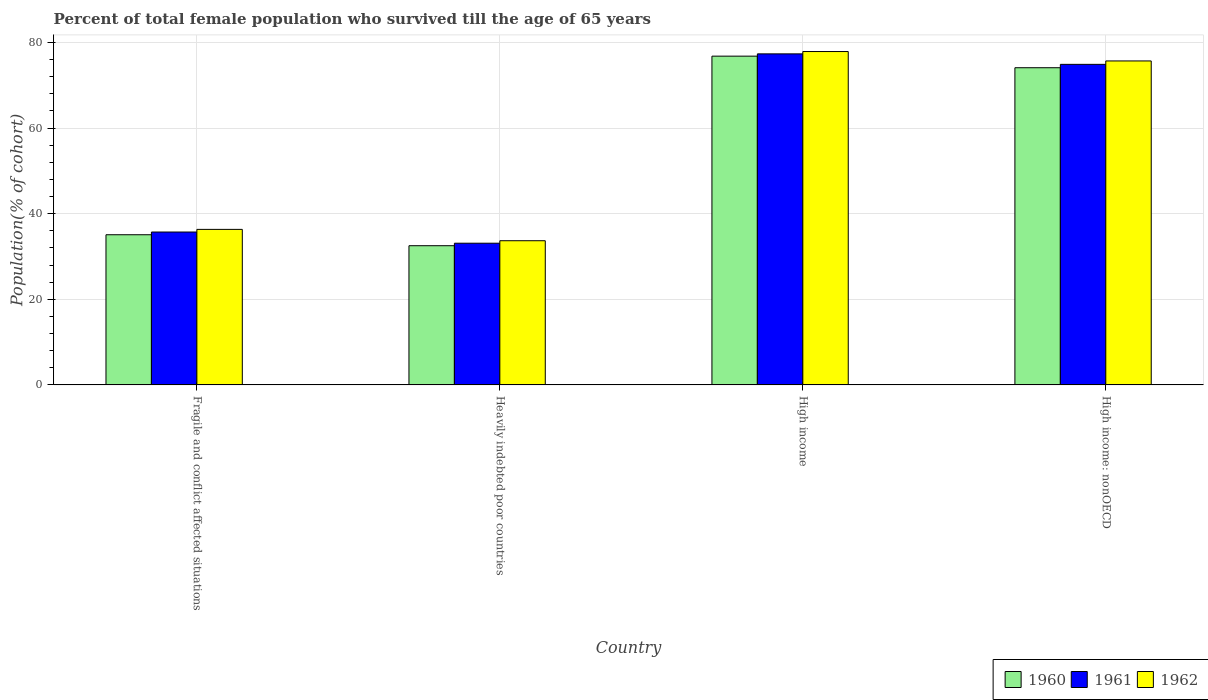How many different coloured bars are there?
Ensure brevity in your answer.  3. Are the number of bars per tick equal to the number of legend labels?
Provide a succinct answer. Yes. How many bars are there on the 4th tick from the left?
Your answer should be compact. 3. How many bars are there on the 3rd tick from the right?
Ensure brevity in your answer.  3. What is the label of the 2nd group of bars from the left?
Offer a terse response. Heavily indebted poor countries. What is the percentage of total female population who survived till the age of 65 years in 1962 in Fragile and conflict affected situations?
Offer a very short reply. 36.34. Across all countries, what is the maximum percentage of total female population who survived till the age of 65 years in 1961?
Your answer should be very brief. 77.34. Across all countries, what is the minimum percentage of total female population who survived till the age of 65 years in 1960?
Provide a short and direct response. 32.52. In which country was the percentage of total female population who survived till the age of 65 years in 1961 maximum?
Ensure brevity in your answer.  High income. In which country was the percentage of total female population who survived till the age of 65 years in 1962 minimum?
Your answer should be very brief. Heavily indebted poor countries. What is the total percentage of total female population who survived till the age of 65 years in 1961 in the graph?
Offer a very short reply. 221.06. What is the difference between the percentage of total female population who survived till the age of 65 years in 1960 in Heavily indebted poor countries and that in High income: nonOECD?
Ensure brevity in your answer.  -41.58. What is the difference between the percentage of total female population who survived till the age of 65 years in 1960 in Fragile and conflict affected situations and the percentage of total female population who survived till the age of 65 years in 1962 in High income?
Offer a terse response. -42.8. What is the average percentage of total female population who survived till the age of 65 years in 1960 per country?
Give a very brief answer. 54.63. What is the difference between the percentage of total female population who survived till the age of 65 years of/in 1962 and percentage of total female population who survived till the age of 65 years of/in 1961 in Fragile and conflict affected situations?
Ensure brevity in your answer.  0.62. What is the ratio of the percentage of total female population who survived till the age of 65 years in 1962 in Fragile and conflict affected situations to that in High income: nonOECD?
Offer a very short reply. 0.48. What is the difference between the highest and the second highest percentage of total female population who survived till the age of 65 years in 1962?
Provide a succinct answer. 39.35. What is the difference between the highest and the lowest percentage of total female population who survived till the age of 65 years in 1960?
Provide a succinct answer. 44.29. In how many countries, is the percentage of total female population who survived till the age of 65 years in 1960 greater than the average percentage of total female population who survived till the age of 65 years in 1960 taken over all countries?
Your answer should be compact. 2. What does the 1st bar from the left in High income: nonOECD represents?
Your answer should be compact. 1960. How many bars are there?
Provide a succinct answer. 12. Are the values on the major ticks of Y-axis written in scientific E-notation?
Your answer should be compact. No. Does the graph contain any zero values?
Your answer should be very brief. No. Does the graph contain grids?
Your answer should be very brief. Yes. How many legend labels are there?
Provide a short and direct response. 3. What is the title of the graph?
Provide a succinct answer. Percent of total female population who survived till the age of 65 years. Does "2000" appear as one of the legend labels in the graph?
Your answer should be very brief. No. What is the label or title of the X-axis?
Your answer should be compact. Country. What is the label or title of the Y-axis?
Offer a very short reply. Population(% of cohort). What is the Population(% of cohort) in 1960 in Fragile and conflict affected situations?
Ensure brevity in your answer.  35.08. What is the Population(% of cohort) in 1961 in Fragile and conflict affected situations?
Make the answer very short. 35.72. What is the Population(% of cohort) in 1962 in Fragile and conflict affected situations?
Give a very brief answer. 36.34. What is the Population(% of cohort) in 1960 in Heavily indebted poor countries?
Make the answer very short. 32.52. What is the Population(% of cohort) in 1961 in Heavily indebted poor countries?
Provide a succinct answer. 33.1. What is the Population(% of cohort) of 1962 in Heavily indebted poor countries?
Offer a very short reply. 33.69. What is the Population(% of cohort) in 1960 in High income?
Your answer should be compact. 76.81. What is the Population(% of cohort) in 1961 in High income?
Offer a very short reply. 77.34. What is the Population(% of cohort) in 1962 in High income?
Your response must be concise. 77.88. What is the Population(% of cohort) of 1960 in High income: nonOECD?
Keep it short and to the point. 74.1. What is the Population(% of cohort) in 1961 in High income: nonOECD?
Offer a very short reply. 74.89. What is the Population(% of cohort) in 1962 in High income: nonOECD?
Offer a very short reply. 75.69. Across all countries, what is the maximum Population(% of cohort) of 1960?
Offer a very short reply. 76.81. Across all countries, what is the maximum Population(% of cohort) of 1961?
Keep it short and to the point. 77.34. Across all countries, what is the maximum Population(% of cohort) in 1962?
Your answer should be compact. 77.88. Across all countries, what is the minimum Population(% of cohort) in 1960?
Offer a very short reply. 32.52. Across all countries, what is the minimum Population(% of cohort) in 1961?
Offer a very short reply. 33.1. Across all countries, what is the minimum Population(% of cohort) of 1962?
Ensure brevity in your answer.  33.69. What is the total Population(% of cohort) of 1960 in the graph?
Keep it short and to the point. 218.52. What is the total Population(% of cohort) of 1961 in the graph?
Ensure brevity in your answer.  221.06. What is the total Population(% of cohort) in 1962 in the graph?
Your answer should be very brief. 223.6. What is the difference between the Population(% of cohort) of 1960 in Fragile and conflict affected situations and that in Heavily indebted poor countries?
Ensure brevity in your answer.  2.56. What is the difference between the Population(% of cohort) in 1961 in Fragile and conflict affected situations and that in Heavily indebted poor countries?
Ensure brevity in your answer.  2.61. What is the difference between the Population(% of cohort) of 1962 in Fragile and conflict affected situations and that in Heavily indebted poor countries?
Give a very brief answer. 2.65. What is the difference between the Population(% of cohort) in 1960 in Fragile and conflict affected situations and that in High income?
Your response must be concise. -41.73. What is the difference between the Population(% of cohort) of 1961 in Fragile and conflict affected situations and that in High income?
Give a very brief answer. -41.62. What is the difference between the Population(% of cohort) of 1962 in Fragile and conflict affected situations and that in High income?
Your response must be concise. -41.55. What is the difference between the Population(% of cohort) of 1960 in Fragile and conflict affected situations and that in High income: nonOECD?
Give a very brief answer. -39.02. What is the difference between the Population(% of cohort) in 1961 in Fragile and conflict affected situations and that in High income: nonOECD?
Offer a terse response. -39.17. What is the difference between the Population(% of cohort) of 1962 in Fragile and conflict affected situations and that in High income: nonOECD?
Make the answer very short. -39.35. What is the difference between the Population(% of cohort) of 1960 in Heavily indebted poor countries and that in High income?
Make the answer very short. -44.29. What is the difference between the Population(% of cohort) in 1961 in Heavily indebted poor countries and that in High income?
Your response must be concise. -44.24. What is the difference between the Population(% of cohort) in 1962 in Heavily indebted poor countries and that in High income?
Your answer should be very brief. -44.2. What is the difference between the Population(% of cohort) of 1960 in Heavily indebted poor countries and that in High income: nonOECD?
Provide a succinct answer. -41.58. What is the difference between the Population(% of cohort) in 1961 in Heavily indebted poor countries and that in High income: nonOECD?
Your answer should be compact. -41.79. What is the difference between the Population(% of cohort) of 1962 in Heavily indebted poor countries and that in High income: nonOECD?
Offer a terse response. -42. What is the difference between the Population(% of cohort) of 1960 in High income and that in High income: nonOECD?
Ensure brevity in your answer.  2.71. What is the difference between the Population(% of cohort) of 1961 in High income and that in High income: nonOECD?
Your answer should be compact. 2.45. What is the difference between the Population(% of cohort) in 1962 in High income and that in High income: nonOECD?
Offer a very short reply. 2.2. What is the difference between the Population(% of cohort) of 1960 in Fragile and conflict affected situations and the Population(% of cohort) of 1961 in Heavily indebted poor countries?
Provide a succinct answer. 1.98. What is the difference between the Population(% of cohort) of 1960 in Fragile and conflict affected situations and the Population(% of cohort) of 1962 in Heavily indebted poor countries?
Offer a very short reply. 1.4. What is the difference between the Population(% of cohort) in 1961 in Fragile and conflict affected situations and the Population(% of cohort) in 1962 in Heavily indebted poor countries?
Give a very brief answer. 2.03. What is the difference between the Population(% of cohort) of 1960 in Fragile and conflict affected situations and the Population(% of cohort) of 1961 in High income?
Give a very brief answer. -42.26. What is the difference between the Population(% of cohort) of 1960 in Fragile and conflict affected situations and the Population(% of cohort) of 1962 in High income?
Make the answer very short. -42.8. What is the difference between the Population(% of cohort) of 1961 in Fragile and conflict affected situations and the Population(% of cohort) of 1962 in High income?
Your response must be concise. -42.17. What is the difference between the Population(% of cohort) of 1960 in Fragile and conflict affected situations and the Population(% of cohort) of 1961 in High income: nonOECD?
Make the answer very short. -39.81. What is the difference between the Population(% of cohort) in 1960 in Fragile and conflict affected situations and the Population(% of cohort) in 1962 in High income: nonOECD?
Your answer should be compact. -40.6. What is the difference between the Population(% of cohort) of 1961 in Fragile and conflict affected situations and the Population(% of cohort) of 1962 in High income: nonOECD?
Offer a terse response. -39.97. What is the difference between the Population(% of cohort) of 1960 in Heavily indebted poor countries and the Population(% of cohort) of 1961 in High income?
Ensure brevity in your answer.  -44.82. What is the difference between the Population(% of cohort) in 1960 in Heavily indebted poor countries and the Population(% of cohort) in 1962 in High income?
Offer a terse response. -45.36. What is the difference between the Population(% of cohort) in 1961 in Heavily indebted poor countries and the Population(% of cohort) in 1962 in High income?
Offer a terse response. -44.78. What is the difference between the Population(% of cohort) in 1960 in Heavily indebted poor countries and the Population(% of cohort) in 1961 in High income: nonOECD?
Ensure brevity in your answer.  -42.37. What is the difference between the Population(% of cohort) of 1960 in Heavily indebted poor countries and the Population(% of cohort) of 1962 in High income: nonOECD?
Make the answer very short. -43.17. What is the difference between the Population(% of cohort) in 1961 in Heavily indebted poor countries and the Population(% of cohort) in 1962 in High income: nonOECD?
Offer a terse response. -42.58. What is the difference between the Population(% of cohort) in 1960 in High income and the Population(% of cohort) in 1961 in High income: nonOECD?
Make the answer very short. 1.92. What is the difference between the Population(% of cohort) in 1960 in High income and the Population(% of cohort) in 1962 in High income: nonOECD?
Provide a succinct answer. 1.12. What is the difference between the Population(% of cohort) in 1961 in High income and the Population(% of cohort) in 1962 in High income: nonOECD?
Offer a very short reply. 1.65. What is the average Population(% of cohort) of 1960 per country?
Your answer should be compact. 54.63. What is the average Population(% of cohort) in 1961 per country?
Offer a terse response. 55.26. What is the average Population(% of cohort) of 1962 per country?
Give a very brief answer. 55.9. What is the difference between the Population(% of cohort) of 1960 and Population(% of cohort) of 1961 in Fragile and conflict affected situations?
Make the answer very short. -0.63. What is the difference between the Population(% of cohort) of 1960 and Population(% of cohort) of 1962 in Fragile and conflict affected situations?
Provide a succinct answer. -1.25. What is the difference between the Population(% of cohort) in 1961 and Population(% of cohort) in 1962 in Fragile and conflict affected situations?
Make the answer very short. -0.62. What is the difference between the Population(% of cohort) of 1960 and Population(% of cohort) of 1961 in Heavily indebted poor countries?
Ensure brevity in your answer.  -0.58. What is the difference between the Population(% of cohort) in 1960 and Population(% of cohort) in 1962 in Heavily indebted poor countries?
Your response must be concise. -1.17. What is the difference between the Population(% of cohort) in 1961 and Population(% of cohort) in 1962 in Heavily indebted poor countries?
Give a very brief answer. -0.58. What is the difference between the Population(% of cohort) of 1960 and Population(% of cohort) of 1961 in High income?
Your response must be concise. -0.53. What is the difference between the Population(% of cohort) in 1960 and Population(% of cohort) in 1962 in High income?
Give a very brief answer. -1.07. What is the difference between the Population(% of cohort) of 1961 and Population(% of cohort) of 1962 in High income?
Provide a succinct answer. -0.54. What is the difference between the Population(% of cohort) in 1960 and Population(% of cohort) in 1961 in High income: nonOECD?
Your answer should be compact. -0.79. What is the difference between the Population(% of cohort) in 1960 and Population(% of cohort) in 1962 in High income: nonOECD?
Your answer should be compact. -1.59. What is the difference between the Population(% of cohort) of 1961 and Population(% of cohort) of 1962 in High income: nonOECD?
Provide a succinct answer. -0.79. What is the ratio of the Population(% of cohort) in 1960 in Fragile and conflict affected situations to that in Heavily indebted poor countries?
Provide a succinct answer. 1.08. What is the ratio of the Population(% of cohort) of 1961 in Fragile and conflict affected situations to that in Heavily indebted poor countries?
Your answer should be compact. 1.08. What is the ratio of the Population(% of cohort) in 1962 in Fragile and conflict affected situations to that in Heavily indebted poor countries?
Keep it short and to the point. 1.08. What is the ratio of the Population(% of cohort) in 1960 in Fragile and conflict affected situations to that in High income?
Your answer should be very brief. 0.46. What is the ratio of the Population(% of cohort) of 1961 in Fragile and conflict affected situations to that in High income?
Your response must be concise. 0.46. What is the ratio of the Population(% of cohort) of 1962 in Fragile and conflict affected situations to that in High income?
Make the answer very short. 0.47. What is the ratio of the Population(% of cohort) in 1960 in Fragile and conflict affected situations to that in High income: nonOECD?
Your answer should be compact. 0.47. What is the ratio of the Population(% of cohort) in 1961 in Fragile and conflict affected situations to that in High income: nonOECD?
Provide a succinct answer. 0.48. What is the ratio of the Population(% of cohort) in 1962 in Fragile and conflict affected situations to that in High income: nonOECD?
Give a very brief answer. 0.48. What is the ratio of the Population(% of cohort) in 1960 in Heavily indebted poor countries to that in High income?
Your response must be concise. 0.42. What is the ratio of the Population(% of cohort) in 1961 in Heavily indebted poor countries to that in High income?
Ensure brevity in your answer.  0.43. What is the ratio of the Population(% of cohort) of 1962 in Heavily indebted poor countries to that in High income?
Provide a succinct answer. 0.43. What is the ratio of the Population(% of cohort) of 1960 in Heavily indebted poor countries to that in High income: nonOECD?
Your answer should be compact. 0.44. What is the ratio of the Population(% of cohort) in 1961 in Heavily indebted poor countries to that in High income: nonOECD?
Offer a terse response. 0.44. What is the ratio of the Population(% of cohort) of 1962 in Heavily indebted poor countries to that in High income: nonOECD?
Give a very brief answer. 0.45. What is the ratio of the Population(% of cohort) in 1960 in High income to that in High income: nonOECD?
Offer a terse response. 1.04. What is the ratio of the Population(% of cohort) in 1961 in High income to that in High income: nonOECD?
Provide a succinct answer. 1.03. What is the difference between the highest and the second highest Population(% of cohort) of 1960?
Keep it short and to the point. 2.71. What is the difference between the highest and the second highest Population(% of cohort) of 1961?
Ensure brevity in your answer.  2.45. What is the difference between the highest and the second highest Population(% of cohort) in 1962?
Your answer should be compact. 2.2. What is the difference between the highest and the lowest Population(% of cohort) of 1960?
Provide a short and direct response. 44.29. What is the difference between the highest and the lowest Population(% of cohort) of 1961?
Provide a succinct answer. 44.24. What is the difference between the highest and the lowest Population(% of cohort) of 1962?
Your answer should be very brief. 44.2. 